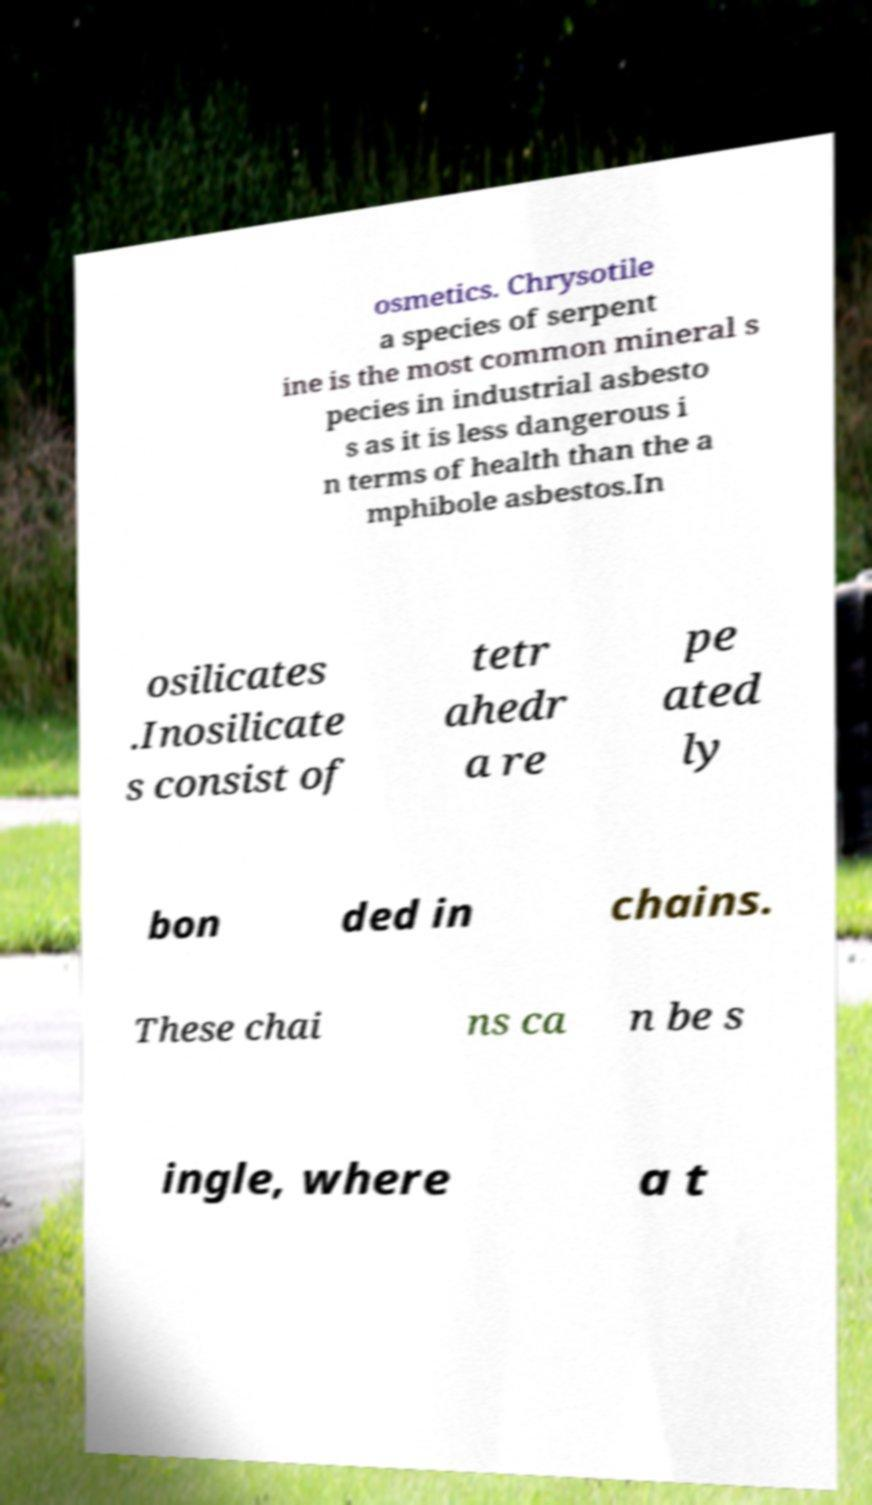Please read and relay the text visible in this image. What does it say? osmetics. Chrysotile a species of serpent ine is the most common mineral s pecies in industrial asbesto s as it is less dangerous i n terms of health than the a mphibole asbestos.In osilicates .Inosilicate s consist of tetr ahedr a re pe ated ly bon ded in chains. These chai ns ca n be s ingle, where a t 